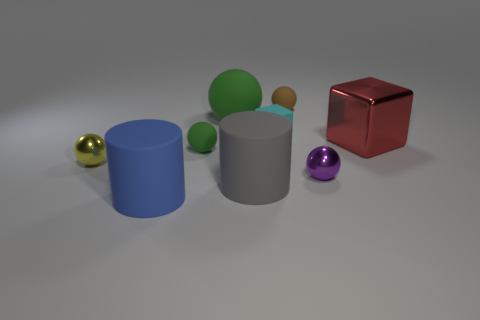There is a blue matte object; is it the same shape as the big gray rubber object on the right side of the small green thing? Yes, the blue matte object is a cylinder, and it's the same shape as the larger gray rubber cylinder to the right of the small green sphere. 